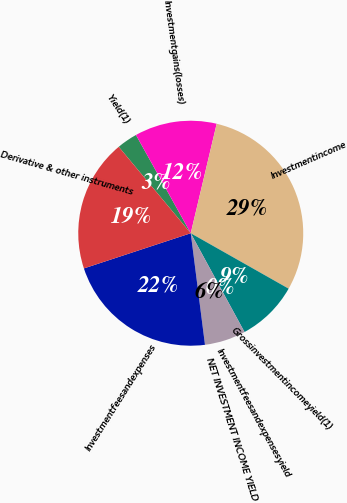Convert chart. <chart><loc_0><loc_0><loc_500><loc_500><pie_chart><fcel>Yield(1)<fcel>Investmentgains(losses)<fcel>Investmentincome<fcel>Grossinvestmentincomeyield(1)<fcel>Investmentfeesandexpensesyield<fcel>NET INVESTMENT INCOME YIELD<fcel>Investmentfeesandexpenses<fcel>Derivative & other instruments<nl><fcel>2.96%<fcel>11.8%<fcel>29.5%<fcel>8.86%<fcel>0.01%<fcel>5.91%<fcel>21.96%<fcel>19.01%<nl></chart> 